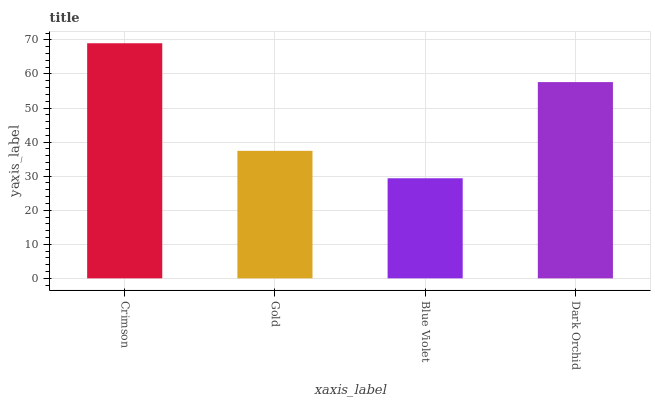Is Blue Violet the minimum?
Answer yes or no. Yes. Is Crimson the maximum?
Answer yes or no. Yes. Is Gold the minimum?
Answer yes or no. No. Is Gold the maximum?
Answer yes or no. No. Is Crimson greater than Gold?
Answer yes or no. Yes. Is Gold less than Crimson?
Answer yes or no. Yes. Is Gold greater than Crimson?
Answer yes or no. No. Is Crimson less than Gold?
Answer yes or no. No. Is Dark Orchid the high median?
Answer yes or no. Yes. Is Gold the low median?
Answer yes or no. Yes. Is Crimson the high median?
Answer yes or no. No. Is Dark Orchid the low median?
Answer yes or no. No. 